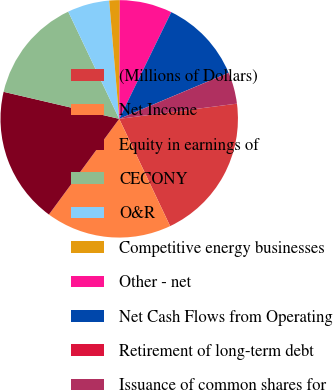Convert chart to OTSL. <chart><loc_0><loc_0><loc_500><loc_500><pie_chart><fcel>(Millions of Dollars)<fcel>Net Income<fcel>Equity in earnings of<fcel>CECONY<fcel>O&R<fcel>Competitive energy businesses<fcel>Other - net<fcel>Net Cash Flows from Operating<fcel>Retirement of long-term debt<fcel>Issuance of common shares for<nl><fcel>19.99%<fcel>17.14%<fcel>18.57%<fcel>14.28%<fcel>5.72%<fcel>1.43%<fcel>7.14%<fcel>11.43%<fcel>0.01%<fcel>4.29%<nl></chart> 